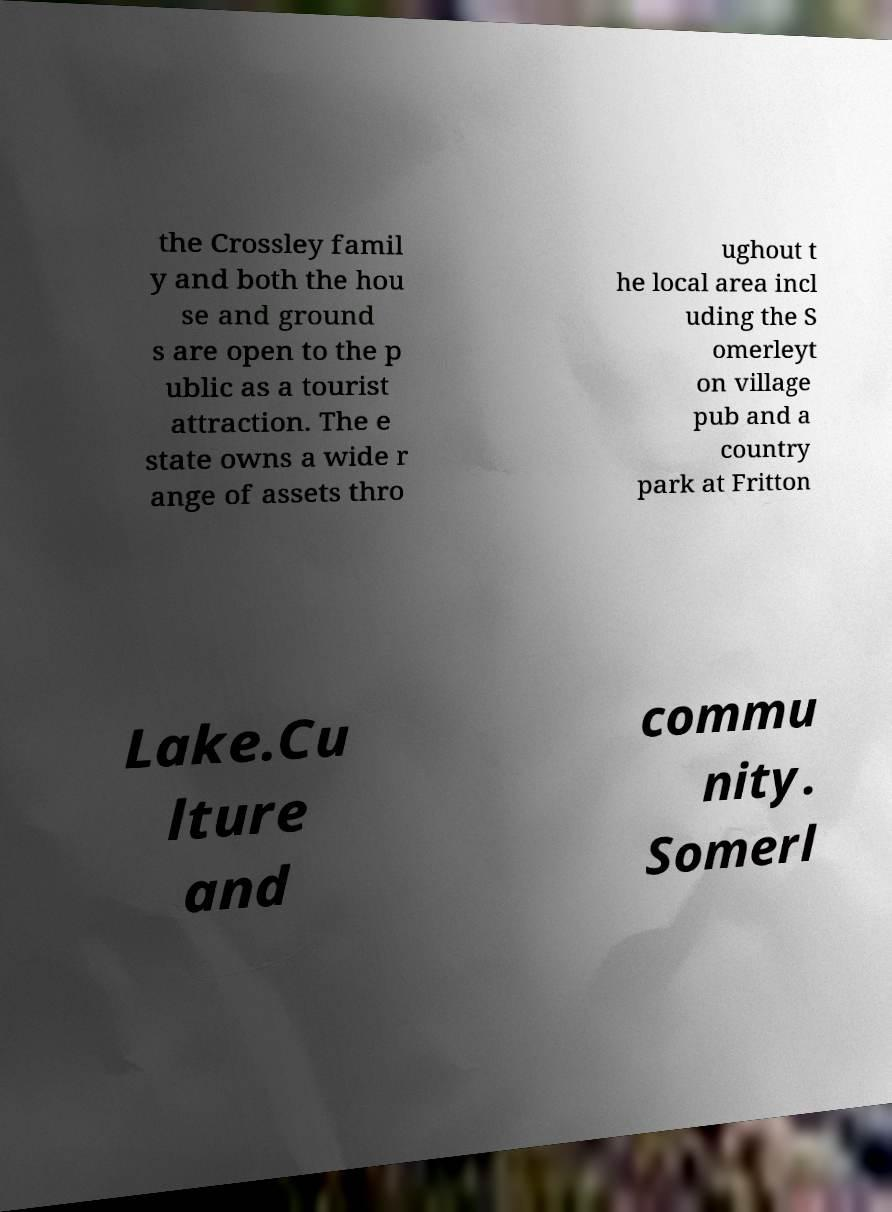Please read and relay the text visible in this image. What does it say? the Crossley famil y and both the hou se and ground s are open to the p ublic as a tourist attraction. The e state owns a wide r ange of assets thro ughout t he local area incl uding the S omerleyt on village pub and a country park at Fritton Lake.Cu lture and commu nity. Somerl 